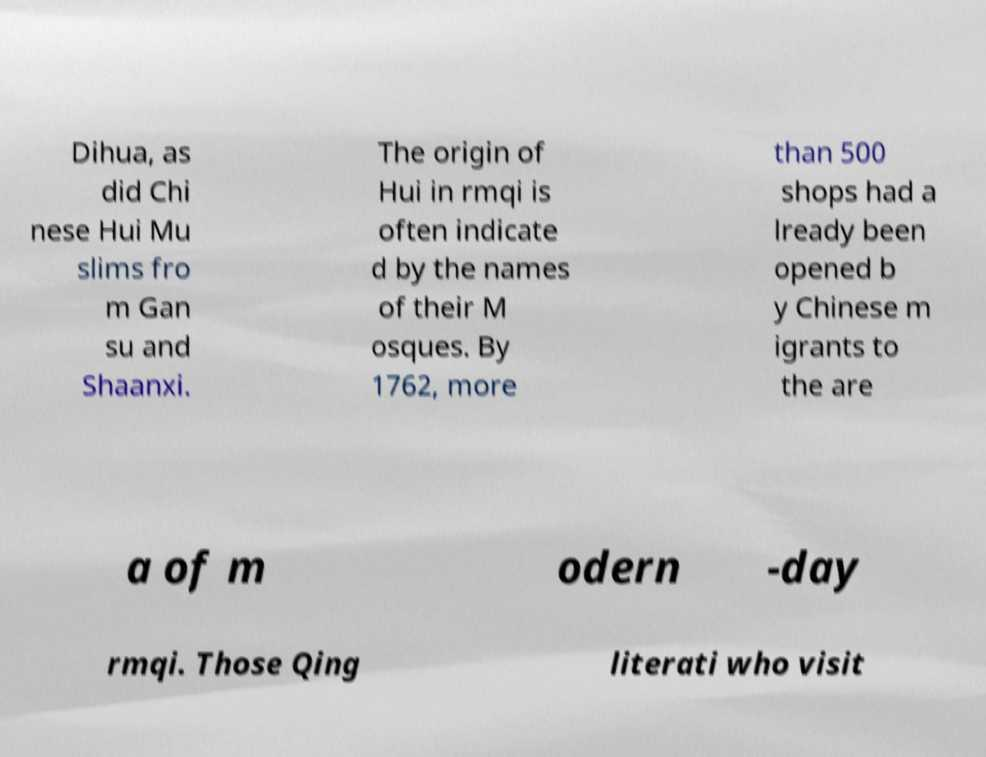Could you assist in decoding the text presented in this image and type it out clearly? Dihua, as did Chi nese Hui Mu slims fro m Gan su and Shaanxi. The origin of Hui in rmqi is often indicate d by the names of their M osques. By 1762, more than 500 shops had a lready been opened b y Chinese m igrants to the are a of m odern -day rmqi. Those Qing literati who visit 